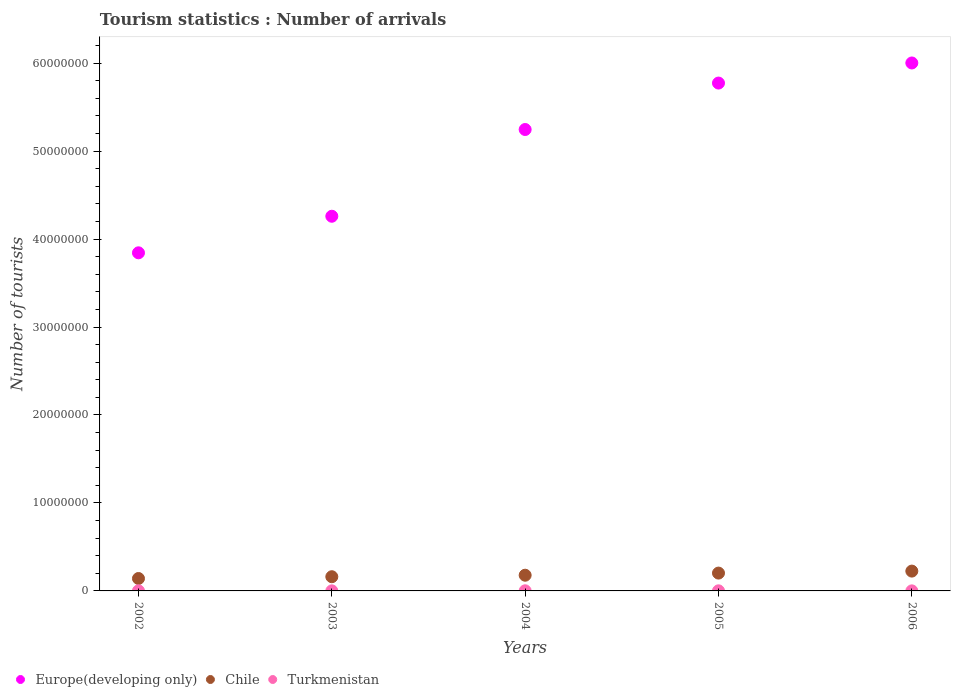Is the number of dotlines equal to the number of legend labels?
Your answer should be compact. Yes. What is the number of tourist arrivals in Chile in 2004?
Ensure brevity in your answer.  1.78e+06. Across all years, what is the maximum number of tourist arrivals in Chile?
Give a very brief answer. 2.25e+06. Across all years, what is the minimum number of tourist arrivals in Europe(developing only)?
Your response must be concise. 3.84e+07. In which year was the number of tourist arrivals in Turkmenistan maximum?
Offer a very short reply. 2004. In which year was the number of tourist arrivals in Turkmenistan minimum?
Provide a succinct answer. 2006. What is the total number of tourist arrivals in Turkmenistan in the graph?
Your response must be concise. 5.20e+04. What is the difference between the number of tourist arrivals in Chile in 2003 and that in 2005?
Give a very brief answer. -4.13e+05. What is the difference between the number of tourist arrivals in Europe(developing only) in 2002 and the number of tourist arrivals in Chile in 2005?
Provide a short and direct response. 3.64e+07. What is the average number of tourist arrivals in Chile per year?
Your answer should be very brief. 1.82e+06. In the year 2005, what is the difference between the number of tourist arrivals in Chile and number of tourist arrivals in Europe(developing only)?
Keep it short and to the point. -5.57e+07. What is the ratio of the number of tourist arrivals in Chile in 2003 to that in 2004?
Provide a succinct answer. 0.9. Is the difference between the number of tourist arrivals in Chile in 2002 and 2006 greater than the difference between the number of tourist arrivals in Europe(developing only) in 2002 and 2006?
Give a very brief answer. Yes. What is the difference between the highest and the second highest number of tourist arrivals in Europe(developing only)?
Offer a very short reply. 2.28e+06. What is the difference between the highest and the lowest number of tourist arrivals in Europe(developing only)?
Provide a succinct answer. 2.16e+07. In how many years, is the number of tourist arrivals in Europe(developing only) greater than the average number of tourist arrivals in Europe(developing only) taken over all years?
Ensure brevity in your answer.  3. Is it the case that in every year, the sum of the number of tourist arrivals in Chile and number of tourist arrivals in Europe(developing only)  is greater than the number of tourist arrivals in Turkmenistan?
Your answer should be compact. Yes. Does the number of tourist arrivals in Europe(developing only) monotonically increase over the years?
Offer a very short reply. Yes. Is the number of tourist arrivals in Europe(developing only) strictly less than the number of tourist arrivals in Chile over the years?
Your answer should be very brief. No. What is the difference between two consecutive major ticks on the Y-axis?
Offer a very short reply. 1.00e+07. Does the graph contain any zero values?
Keep it short and to the point. No. How many legend labels are there?
Give a very brief answer. 3. How are the legend labels stacked?
Your answer should be very brief. Horizontal. What is the title of the graph?
Give a very brief answer. Tourism statistics : Number of arrivals. What is the label or title of the X-axis?
Offer a very short reply. Years. What is the label or title of the Y-axis?
Your answer should be very brief. Number of tourists. What is the Number of tourists in Europe(developing only) in 2002?
Give a very brief answer. 3.84e+07. What is the Number of tourists in Chile in 2002?
Offer a very short reply. 1.41e+06. What is the Number of tourists of Turkmenistan in 2002?
Offer a terse response. 1.10e+04. What is the Number of tourists in Europe(developing only) in 2003?
Ensure brevity in your answer.  4.26e+07. What is the Number of tourists of Chile in 2003?
Give a very brief answer. 1.61e+06. What is the Number of tourists in Turkmenistan in 2003?
Keep it short and to the point. 8000. What is the Number of tourists of Europe(developing only) in 2004?
Your answer should be very brief. 5.24e+07. What is the Number of tourists in Chile in 2004?
Keep it short and to the point. 1.78e+06. What is the Number of tourists in Turkmenistan in 2004?
Ensure brevity in your answer.  1.50e+04. What is the Number of tourists in Europe(developing only) in 2005?
Ensure brevity in your answer.  5.77e+07. What is the Number of tourists of Chile in 2005?
Give a very brief answer. 2.03e+06. What is the Number of tourists of Turkmenistan in 2005?
Ensure brevity in your answer.  1.20e+04. What is the Number of tourists in Europe(developing only) in 2006?
Offer a very short reply. 6.00e+07. What is the Number of tourists in Chile in 2006?
Offer a terse response. 2.25e+06. What is the Number of tourists of Turkmenistan in 2006?
Offer a terse response. 6000. Across all years, what is the maximum Number of tourists in Europe(developing only)?
Your answer should be very brief. 6.00e+07. Across all years, what is the maximum Number of tourists of Chile?
Your answer should be very brief. 2.25e+06. Across all years, what is the maximum Number of tourists of Turkmenistan?
Provide a short and direct response. 1.50e+04. Across all years, what is the minimum Number of tourists of Europe(developing only)?
Your answer should be very brief. 3.84e+07. Across all years, what is the minimum Number of tourists in Chile?
Ensure brevity in your answer.  1.41e+06. Across all years, what is the minimum Number of tourists in Turkmenistan?
Provide a succinct answer. 6000. What is the total Number of tourists of Europe(developing only) in the graph?
Make the answer very short. 2.51e+08. What is the total Number of tourists of Chile in the graph?
Keep it short and to the point. 9.09e+06. What is the total Number of tourists of Turkmenistan in the graph?
Provide a short and direct response. 5.20e+04. What is the difference between the Number of tourists in Europe(developing only) in 2002 and that in 2003?
Provide a short and direct response. -4.16e+06. What is the difference between the Number of tourists of Chile in 2002 and that in 2003?
Ensure brevity in your answer.  -2.02e+05. What is the difference between the Number of tourists of Turkmenistan in 2002 and that in 2003?
Your answer should be compact. 3000. What is the difference between the Number of tourists in Europe(developing only) in 2002 and that in 2004?
Make the answer very short. -1.40e+07. What is the difference between the Number of tourists in Chile in 2002 and that in 2004?
Provide a short and direct response. -3.73e+05. What is the difference between the Number of tourists of Turkmenistan in 2002 and that in 2004?
Give a very brief answer. -4000. What is the difference between the Number of tourists of Europe(developing only) in 2002 and that in 2005?
Keep it short and to the point. -1.93e+07. What is the difference between the Number of tourists of Chile in 2002 and that in 2005?
Make the answer very short. -6.15e+05. What is the difference between the Number of tourists in Turkmenistan in 2002 and that in 2005?
Give a very brief answer. -1000. What is the difference between the Number of tourists of Europe(developing only) in 2002 and that in 2006?
Make the answer very short. -2.16e+07. What is the difference between the Number of tourists of Chile in 2002 and that in 2006?
Keep it short and to the point. -8.41e+05. What is the difference between the Number of tourists of Turkmenistan in 2002 and that in 2006?
Ensure brevity in your answer.  5000. What is the difference between the Number of tourists in Europe(developing only) in 2003 and that in 2004?
Offer a terse response. -9.86e+06. What is the difference between the Number of tourists in Chile in 2003 and that in 2004?
Provide a short and direct response. -1.71e+05. What is the difference between the Number of tourists of Turkmenistan in 2003 and that in 2004?
Your response must be concise. -7000. What is the difference between the Number of tourists in Europe(developing only) in 2003 and that in 2005?
Ensure brevity in your answer.  -1.51e+07. What is the difference between the Number of tourists of Chile in 2003 and that in 2005?
Keep it short and to the point. -4.13e+05. What is the difference between the Number of tourists of Turkmenistan in 2003 and that in 2005?
Give a very brief answer. -4000. What is the difference between the Number of tourists in Europe(developing only) in 2003 and that in 2006?
Your answer should be very brief. -1.74e+07. What is the difference between the Number of tourists of Chile in 2003 and that in 2006?
Provide a succinct answer. -6.39e+05. What is the difference between the Number of tourists in Turkmenistan in 2003 and that in 2006?
Offer a terse response. 2000. What is the difference between the Number of tourists in Europe(developing only) in 2004 and that in 2005?
Ensure brevity in your answer.  -5.28e+06. What is the difference between the Number of tourists of Chile in 2004 and that in 2005?
Your answer should be very brief. -2.42e+05. What is the difference between the Number of tourists of Turkmenistan in 2004 and that in 2005?
Provide a short and direct response. 3000. What is the difference between the Number of tourists in Europe(developing only) in 2004 and that in 2006?
Your answer should be compact. -7.56e+06. What is the difference between the Number of tourists of Chile in 2004 and that in 2006?
Your answer should be compact. -4.68e+05. What is the difference between the Number of tourists of Turkmenistan in 2004 and that in 2006?
Offer a terse response. 9000. What is the difference between the Number of tourists of Europe(developing only) in 2005 and that in 2006?
Offer a very short reply. -2.28e+06. What is the difference between the Number of tourists in Chile in 2005 and that in 2006?
Offer a terse response. -2.26e+05. What is the difference between the Number of tourists of Turkmenistan in 2005 and that in 2006?
Give a very brief answer. 6000. What is the difference between the Number of tourists in Europe(developing only) in 2002 and the Number of tourists in Chile in 2003?
Keep it short and to the point. 3.68e+07. What is the difference between the Number of tourists of Europe(developing only) in 2002 and the Number of tourists of Turkmenistan in 2003?
Make the answer very short. 3.84e+07. What is the difference between the Number of tourists in Chile in 2002 and the Number of tourists in Turkmenistan in 2003?
Keep it short and to the point. 1.40e+06. What is the difference between the Number of tourists in Europe(developing only) in 2002 and the Number of tourists in Chile in 2004?
Keep it short and to the point. 3.66e+07. What is the difference between the Number of tourists of Europe(developing only) in 2002 and the Number of tourists of Turkmenistan in 2004?
Keep it short and to the point. 3.84e+07. What is the difference between the Number of tourists in Chile in 2002 and the Number of tourists in Turkmenistan in 2004?
Make the answer very short. 1.40e+06. What is the difference between the Number of tourists of Europe(developing only) in 2002 and the Number of tourists of Chile in 2005?
Your answer should be very brief. 3.64e+07. What is the difference between the Number of tourists of Europe(developing only) in 2002 and the Number of tourists of Turkmenistan in 2005?
Keep it short and to the point. 3.84e+07. What is the difference between the Number of tourists of Chile in 2002 and the Number of tourists of Turkmenistan in 2005?
Keep it short and to the point. 1.40e+06. What is the difference between the Number of tourists in Europe(developing only) in 2002 and the Number of tourists in Chile in 2006?
Keep it short and to the point. 3.62e+07. What is the difference between the Number of tourists of Europe(developing only) in 2002 and the Number of tourists of Turkmenistan in 2006?
Keep it short and to the point. 3.84e+07. What is the difference between the Number of tourists of Chile in 2002 and the Number of tourists of Turkmenistan in 2006?
Offer a very short reply. 1.41e+06. What is the difference between the Number of tourists in Europe(developing only) in 2003 and the Number of tourists in Chile in 2004?
Give a very brief answer. 4.08e+07. What is the difference between the Number of tourists of Europe(developing only) in 2003 and the Number of tourists of Turkmenistan in 2004?
Your answer should be compact. 4.26e+07. What is the difference between the Number of tourists in Chile in 2003 and the Number of tourists in Turkmenistan in 2004?
Offer a terse response. 1.60e+06. What is the difference between the Number of tourists in Europe(developing only) in 2003 and the Number of tourists in Chile in 2005?
Make the answer very short. 4.06e+07. What is the difference between the Number of tourists in Europe(developing only) in 2003 and the Number of tourists in Turkmenistan in 2005?
Your response must be concise. 4.26e+07. What is the difference between the Number of tourists of Chile in 2003 and the Number of tourists of Turkmenistan in 2005?
Offer a very short reply. 1.60e+06. What is the difference between the Number of tourists in Europe(developing only) in 2003 and the Number of tourists in Chile in 2006?
Make the answer very short. 4.03e+07. What is the difference between the Number of tourists of Europe(developing only) in 2003 and the Number of tourists of Turkmenistan in 2006?
Give a very brief answer. 4.26e+07. What is the difference between the Number of tourists of Chile in 2003 and the Number of tourists of Turkmenistan in 2006?
Offer a terse response. 1.61e+06. What is the difference between the Number of tourists in Europe(developing only) in 2004 and the Number of tourists in Chile in 2005?
Keep it short and to the point. 5.04e+07. What is the difference between the Number of tourists of Europe(developing only) in 2004 and the Number of tourists of Turkmenistan in 2005?
Ensure brevity in your answer.  5.24e+07. What is the difference between the Number of tourists in Chile in 2004 and the Number of tourists in Turkmenistan in 2005?
Give a very brief answer. 1.77e+06. What is the difference between the Number of tourists in Europe(developing only) in 2004 and the Number of tourists in Chile in 2006?
Make the answer very short. 5.02e+07. What is the difference between the Number of tourists in Europe(developing only) in 2004 and the Number of tourists in Turkmenistan in 2006?
Give a very brief answer. 5.24e+07. What is the difference between the Number of tourists of Chile in 2004 and the Number of tourists of Turkmenistan in 2006?
Give a very brief answer. 1.78e+06. What is the difference between the Number of tourists of Europe(developing only) in 2005 and the Number of tourists of Chile in 2006?
Offer a very short reply. 5.55e+07. What is the difference between the Number of tourists of Europe(developing only) in 2005 and the Number of tourists of Turkmenistan in 2006?
Provide a short and direct response. 5.77e+07. What is the difference between the Number of tourists of Chile in 2005 and the Number of tourists of Turkmenistan in 2006?
Offer a terse response. 2.02e+06. What is the average Number of tourists in Europe(developing only) per year?
Ensure brevity in your answer.  5.02e+07. What is the average Number of tourists in Chile per year?
Your answer should be compact. 1.82e+06. What is the average Number of tourists of Turkmenistan per year?
Your response must be concise. 1.04e+04. In the year 2002, what is the difference between the Number of tourists of Europe(developing only) and Number of tourists of Chile?
Offer a terse response. 3.70e+07. In the year 2002, what is the difference between the Number of tourists in Europe(developing only) and Number of tourists in Turkmenistan?
Provide a succinct answer. 3.84e+07. In the year 2002, what is the difference between the Number of tourists in Chile and Number of tourists in Turkmenistan?
Keep it short and to the point. 1.40e+06. In the year 2003, what is the difference between the Number of tourists of Europe(developing only) and Number of tourists of Chile?
Your response must be concise. 4.10e+07. In the year 2003, what is the difference between the Number of tourists of Europe(developing only) and Number of tourists of Turkmenistan?
Offer a terse response. 4.26e+07. In the year 2003, what is the difference between the Number of tourists of Chile and Number of tourists of Turkmenistan?
Keep it short and to the point. 1.61e+06. In the year 2004, what is the difference between the Number of tourists in Europe(developing only) and Number of tourists in Chile?
Your answer should be compact. 5.07e+07. In the year 2004, what is the difference between the Number of tourists of Europe(developing only) and Number of tourists of Turkmenistan?
Provide a succinct answer. 5.24e+07. In the year 2004, what is the difference between the Number of tourists of Chile and Number of tourists of Turkmenistan?
Offer a very short reply. 1.77e+06. In the year 2005, what is the difference between the Number of tourists in Europe(developing only) and Number of tourists in Chile?
Offer a terse response. 5.57e+07. In the year 2005, what is the difference between the Number of tourists of Europe(developing only) and Number of tourists of Turkmenistan?
Your answer should be very brief. 5.77e+07. In the year 2005, what is the difference between the Number of tourists in Chile and Number of tourists in Turkmenistan?
Ensure brevity in your answer.  2.02e+06. In the year 2006, what is the difference between the Number of tourists in Europe(developing only) and Number of tourists in Chile?
Give a very brief answer. 5.78e+07. In the year 2006, what is the difference between the Number of tourists of Europe(developing only) and Number of tourists of Turkmenistan?
Your answer should be compact. 6.00e+07. In the year 2006, what is the difference between the Number of tourists in Chile and Number of tourists in Turkmenistan?
Provide a short and direct response. 2.25e+06. What is the ratio of the Number of tourists in Europe(developing only) in 2002 to that in 2003?
Ensure brevity in your answer.  0.9. What is the ratio of the Number of tourists of Chile in 2002 to that in 2003?
Provide a succinct answer. 0.87. What is the ratio of the Number of tourists in Turkmenistan in 2002 to that in 2003?
Keep it short and to the point. 1.38. What is the ratio of the Number of tourists of Europe(developing only) in 2002 to that in 2004?
Provide a succinct answer. 0.73. What is the ratio of the Number of tourists in Chile in 2002 to that in 2004?
Provide a succinct answer. 0.79. What is the ratio of the Number of tourists in Turkmenistan in 2002 to that in 2004?
Provide a short and direct response. 0.73. What is the ratio of the Number of tourists of Europe(developing only) in 2002 to that in 2005?
Your answer should be very brief. 0.67. What is the ratio of the Number of tourists of Chile in 2002 to that in 2005?
Offer a very short reply. 0.7. What is the ratio of the Number of tourists of Europe(developing only) in 2002 to that in 2006?
Give a very brief answer. 0.64. What is the ratio of the Number of tourists in Chile in 2002 to that in 2006?
Your answer should be very brief. 0.63. What is the ratio of the Number of tourists of Turkmenistan in 2002 to that in 2006?
Give a very brief answer. 1.83. What is the ratio of the Number of tourists of Europe(developing only) in 2003 to that in 2004?
Ensure brevity in your answer.  0.81. What is the ratio of the Number of tourists in Chile in 2003 to that in 2004?
Provide a succinct answer. 0.9. What is the ratio of the Number of tourists of Turkmenistan in 2003 to that in 2004?
Offer a terse response. 0.53. What is the ratio of the Number of tourists in Europe(developing only) in 2003 to that in 2005?
Offer a terse response. 0.74. What is the ratio of the Number of tourists in Chile in 2003 to that in 2005?
Give a very brief answer. 0.8. What is the ratio of the Number of tourists in Europe(developing only) in 2003 to that in 2006?
Your response must be concise. 0.71. What is the ratio of the Number of tourists in Chile in 2003 to that in 2006?
Your answer should be very brief. 0.72. What is the ratio of the Number of tourists of Europe(developing only) in 2004 to that in 2005?
Provide a succinct answer. 0.91. What is the ratio of the Number of tourists of Chile in 2004 to that in 2005?
Offer a terse response. 0.88. What is the ratio of the Number of tourists of Turkmenistan in 2004 to that in 2005?
Provide a short and direct response. 1.25. What is the ratio of the Number of tourists of Europe(developing only) in 2004 to that in 2006?
Your answer should be very brief. 0.87. What is the ratio of the Number of tourists of Chile in 2004 to that in 2006?
Make the answer very short. 0.79. What is the ratio of the Number of tourists in Europe(developing only) in 2005 to that in 2006?
Give a very brief answer. 0.96. What is the ratio of the Number of tourists of Chile in 2005 to that in 2006?
Keep it short and to the point. 0.9. What is the ratio of the Number of tourists of Turkmenistan in 2005 to that in 2006?
Your response must be concise. 2. What is the difference between the highest and the second highest Number of tourists of Europe(developing only)?
Offer a very short reply. 2.28e+06. What is the difference between the highest and the second highest Number of tourists of Chile?
Provide a succinct answer. 2.26e+05. What is the difference between the highest and the second highest Number of tourists in Turkmenistan?
Your answer should be very brief. 3000. What is the difference between the highest and the lowest Number of tourists in Europe(developing only)?
Provide a succinct answer. 2.16e+07. What is the difference between the highest and the lowest Number of tourists in Chile?
Offer a terse response. 8.41e+05. What is the difference between the highest and the lowest Number of tourists of Turkmenistan?
Your answer should be compact. 9000. 